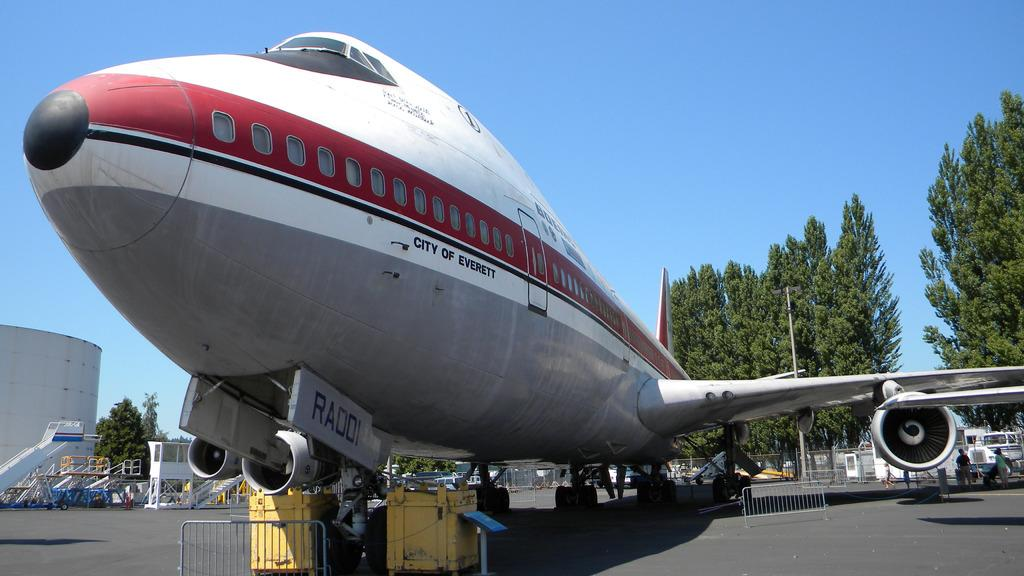<image>
Write a terse but informative summary of the picture. the nose of an old airplane with the words "City of Everett" on the side 